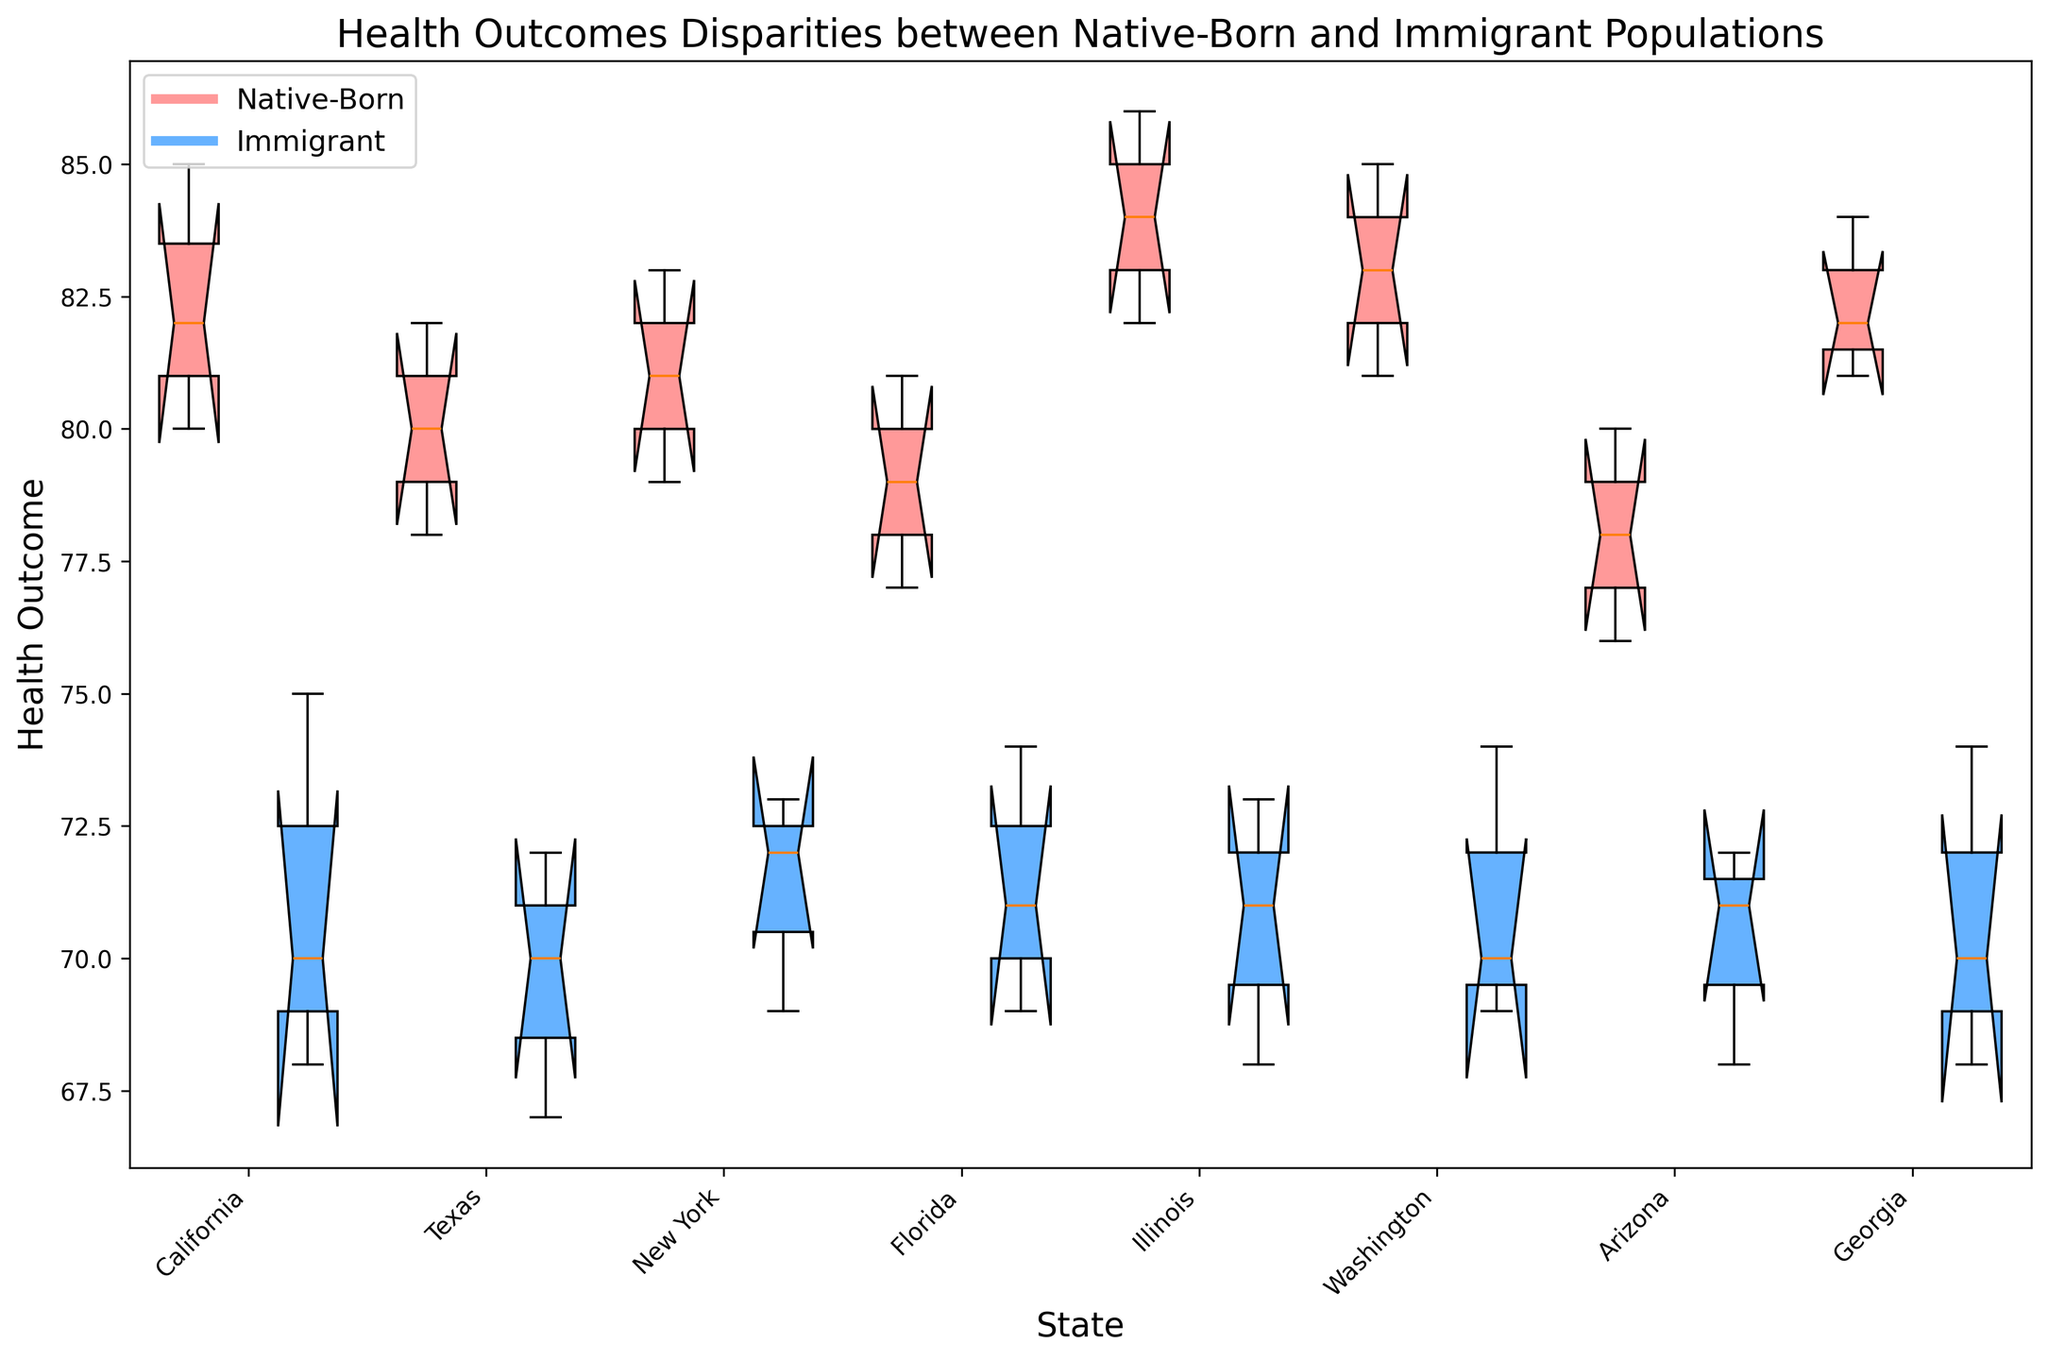Which state shows the smallest disparity between native-born and immigrant health outcomes? Look at the distance between the medians (the center lines) of the box plots for native-born and immigrant populations in each state. The state with the smallest gap indicates the smallest disparity.
Answer: Florida In which state do immigrant populations have the lowest median health outcome? Identify the median (center line) within the boxes for immigrant populations across all states and select the state with the lowest median line.
Answer: Texas Which group's health outcomes show more variation in California: native-born or immigrant? Compare the height of the boxes (interquartile range) for native-born and immigrant populations in California. The taller box indicates more variation.
Answer: Immigrant Do native-born populations generally show better health outcomes than immigrant populations across all states? Observe the median lines (center lines) of the box plots for native-born and immigrant populations in all states. If native-born median lines are generally higher, this means they have better health outcomes.
Answer: Yes Which state has the highest upper quartile for native-born populations? Look at the top boundary of the boxes (representing the upper quartile) for native-born populations in all states. Identify the state where this boundary is highest.
Answer: Illinois What is the median health outcome for native-born populations in Illinois? Identify the center line of the native-born box plot in Illinois and read the value directly off the y-axis.
Answer: 84 Is there any state where the interquartile range (IQR) for immigrant populations is smaller than that for native-born populations? Compare the height of the boxes (representing the IQR) for each state. See if any immigrant box is shorter than the native-born box for that state.
Answer: No Which state has the most significant variation in health outcomes for native-born populations? Determine the state with the tallest box (longest interquartile range) for native-born populations, indicating the most variation.
Answer: California What visual patterns indicate differences in health outcomes between native-born and immigrant populations? Observe the color patterns of the boxes (red for native-born and blue for immigrant) and their positions. Patterns may include consistent color dominance at higher or lower y-axis positions.
Answer: Red boxes generally higher In which state do immigrant populations display the highest median health outcome? Locate the center lines within the immigrant (blue) boxes for all states and identify the highest median value.
Answer: Washington 